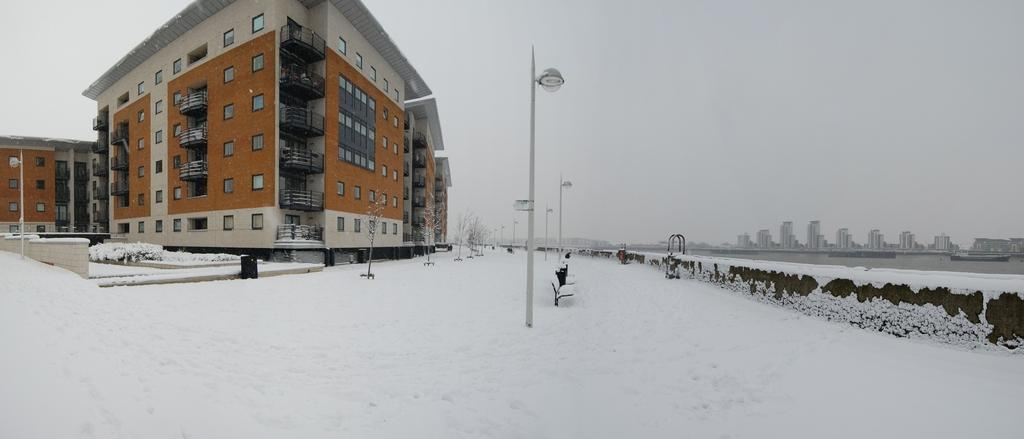What is the ground made of at the bottom of the image? There is snow at the bottom of the image. What can be seen in the middle of the image? There are poles, buildings, and plants in the middle of the image. What is visible at the top of the image? The sky is visible at the top of the image. What is the title of the agreement between the plants and the buildings in the image? There is no agreement mentioned in the image, and the plants and buildings are not interacting in a way that would suggest an agreement. How does the image demonstrate respect between the snow and the sky? The image does not depict any interaction or relationship between the snow and the sky that would suggest respect. 